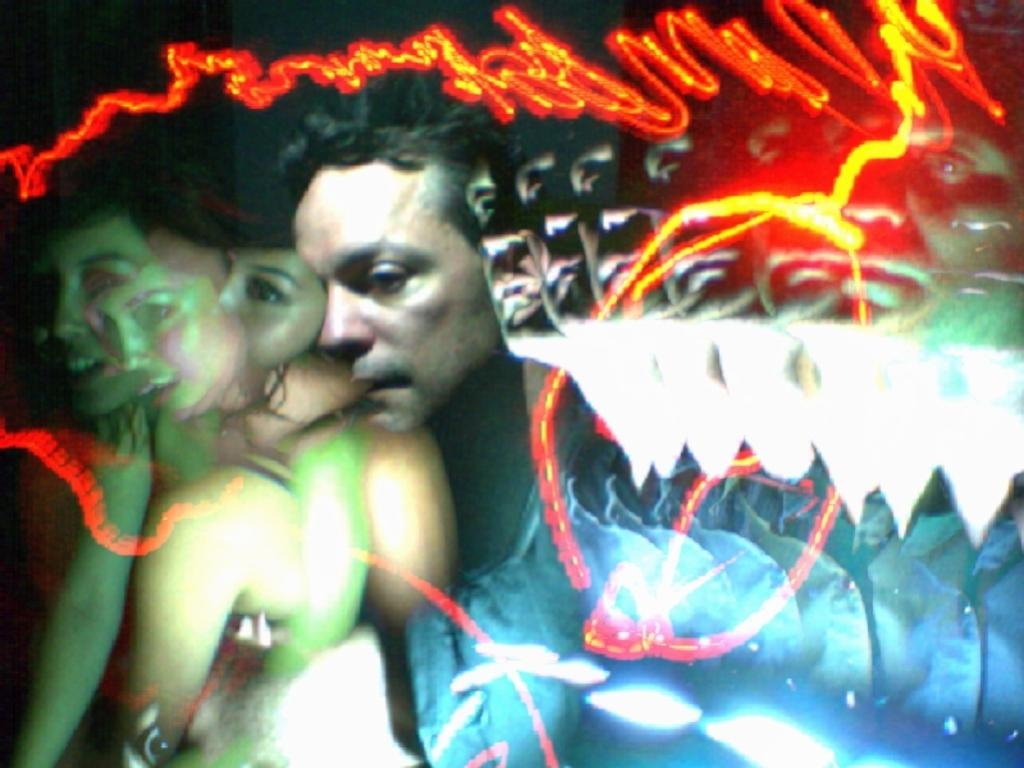What can be seen in the image in terms of human features? There are faces of people in the image. What color stands out in the image? There is a red color thing in the image. How would you describe the clarity of the image? The image is blurry. Can you tell me how many arches are visible in the image? There are no arches present in the image. What type of harbor can be seen in the image? There is no harbor present in the image. 